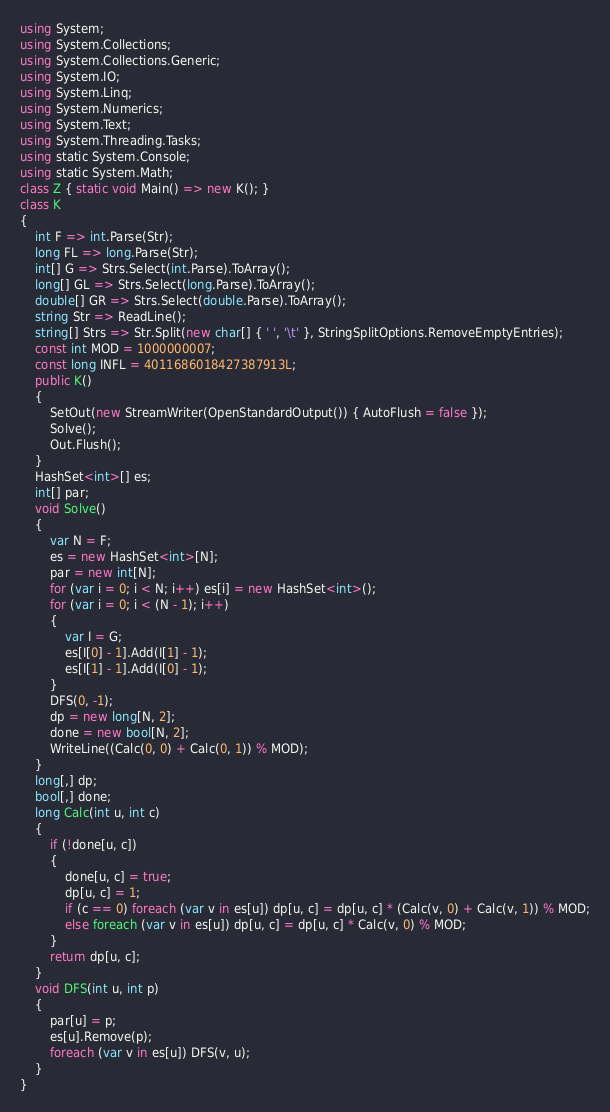<code> <loc_0><loc_0><loc_500><loc_500><_C#_>using System;
using System.Collections;
using System.Collections.Generic;
using System.IO;
using System.Linq;
using System.Numerics;
using System.Text;
using System.Threading.Tasks;
using static System.Console;
using static System.Math;
class Z { static void Main() => new K(); }
class K
{
	int F => int.Parse(Str);
	long FL => long.Parse(Str);
	int[] G => Strs.Select(int.Parse).ToArray();
	long[] GL => Strs.Select(long.Parse).ToArray();
	double[] GR => Strs.Select(double.Parse).ToArray();
	string Str => ReadLine();
	string[] Strs => Str.Split(new char[] { ' ', '\t' }, StringSplitOptions.RemoveEmptyEntries);
	const int MOD = 1000000007;
	const long INFL = 4011686018427387913L;
	public K()
	{
		SetOut(new StreamWriter(OpenStandardOutput()) { AutoFlush = false });
		Solve();
		Out.Flush();
	}
	HashSet<int>[] es;
	int[] par;
	void Solve()
	{
		var N = F;
		es = new HashSet<int>[N];
		par = new int[N];
		for (var i = 0; i < N; i++) es[i] = new HashSet<int>();
		for (var i = 0; i < (N - 1); i++)
		{
			var I = G;
			es[I[0] - 1].Add(I[1] - 1);
			es[I[1] - 1].Add(I[0] - 1);
		}
		DFS(0, -1);
		dp = new long[N, 2];
		done = new bool[N, 2];
		WriteLine((Calc(0, 0) + Calc(0, 1)) % MOD);
	}
	long[,] dp;
	bool[,] done;
	long Calc(int u, int c)
	{
		if (!done[u, c])
		{
			done[u, c] = true;
			dp[u, c] = 1;
			if (c == 0) foreach (var v in es[u]) dp[u, c] = dp[u, c] * (Calc(v, 0) + Calc(v, 1)) % MOD;
			else foreach (var v in es[u]) dp[u, c] = dp[u, c] * Calc(v, 0) % MOD;
		}
		return dp[u, c];
	}
	void DFS(int u, int p)
	{
		par[u] = p;
		es[u].Remove(p);
		foreach (var v in es[u]) DFS(v, u);
	}
}
</code> 